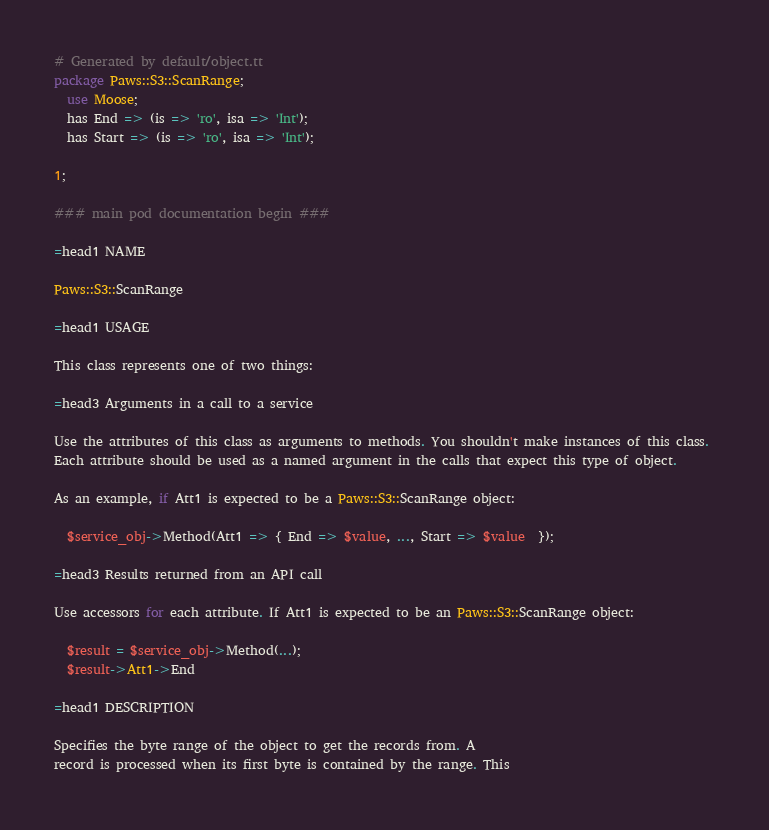Convert code to text. <code><loc_0><loc_0><loc_500><loc_500><_Perl_># Generated by default/object.tt
package Paws::S3::ScanRange;
  use Moose;
  has End => (is => 'ro', isa => 'Int');
  has Start => (is => 'ro', isa => 'Int');

1;

### main pod documentation begin ###

=head1 NAME

Paws::S3::ScanRange

=head1 USAGE

This class represents one of two things:

=head3 Arguments in a call to a service

Use the attributes of this class as arguments to methods. You shouldn't make instances of this class. 
Each attribute should be used as a named argument in the calls that expect this type of object.

As an example, if Att1 is expected to be a Paws::S3::ScanRange object:

  $service_obj->Method(Att1 => { End => $value, ..., Start => $value  });

=head3 Results returned from an API call

Use accessors for each attribute. If Att1 is expected to be an Paws::S3::ScanRange object:

  $result = $service_obj->Method(...);
  $result->Att1->End

=head1 DESCRIPTION

Specifies the byte range of the object to get the records from. A
record is processed when its first byte is contained by the range. This</code> 